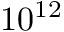Convert formula to latex. <formula><loc_0><loc_0><loc_500><loc_500>1 0 ^ { 1 2 }</formula> 